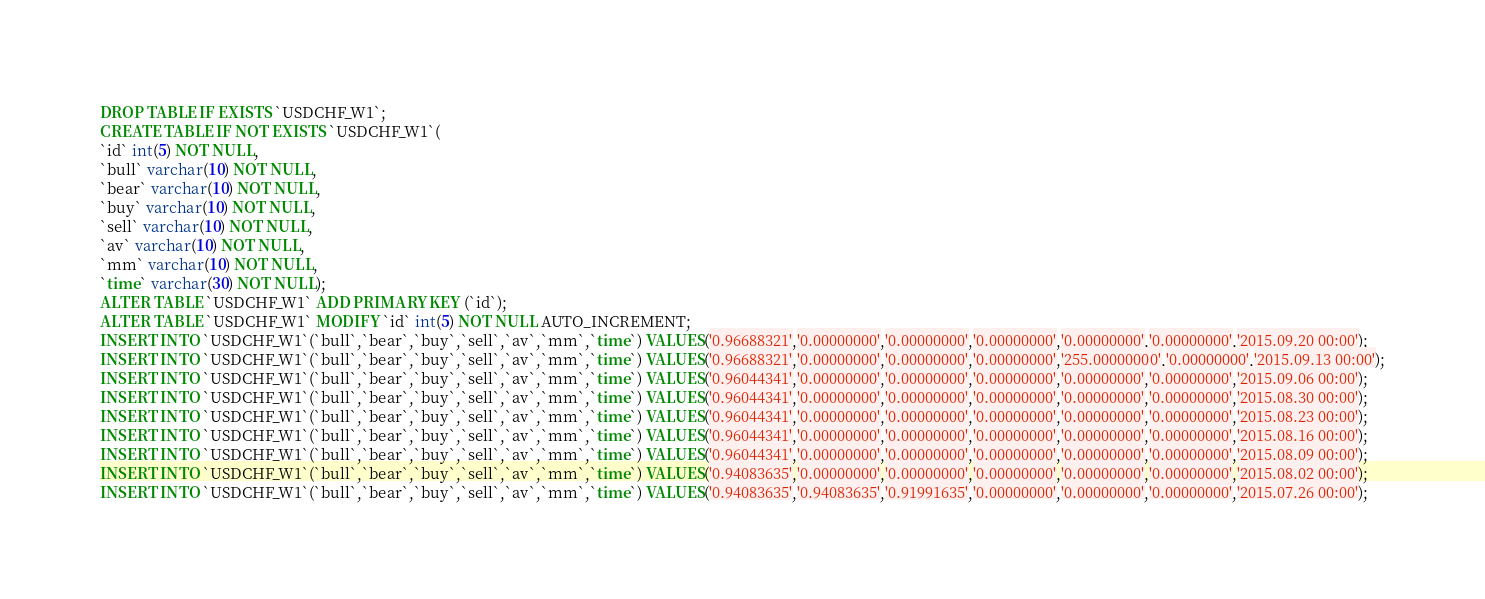<code> <loc_0><loc_0><loc_500><loc_500><_SQL_>DROP TABLE IF EXISTS `USDCHF_W1`;
CREATE TABLE IF NOT EXISTS `USDCHF_W1`(
`id` int(5) NOT NULL,
`bull` varchar(10) NOT NULL,
`bear` varchar(10) NOT NULL,
`buy` varchar(10) NOT NULL,
`sell` varchar(10) NOT NULL,
`av` varchar(10) NOT NULL,
`mm` varchar(10) NOT NULL,
`time` varchar(30) NOT NULL);
ALTER TABLE `USDCHF_W1` ADD PRIMARY KEY (`id`);
ALTER TABLE `USDCHF_W1` MODIFY `id` int(5) NOT NULL AUTO_INCREMENT;
INSERT INTO `USDCHF_W1`(`bull`,`bear`,`buy`,`sell`,`av`,`mm`,`time`) VALUES('0.96688321','0.00000000','0.00000000','0.00000000','0.00000000','0.00000000','2015.09.20 00:00');
INSERT INTO `USDCHF_W1`(`bull`,`bear`,`buy`,`sell`,`av`,`mm`,`time`) VALUES('0.96688321','0.00000000','0.00000000','0.00000000','255.00000000','0.00000000','2015.09.13 00:00');
INSERT INTO `USDCHF_W1`(`bull`,`bear`,`buy`,`sell`,`av`,`mm`,`time`) VALUES('0.96044341','0.00000000','0.00000000','0.00000000','0.00000000','0.00000000','2015.09.06 00:00');
INSERT INTO `USDCHF_W1`(`bull`,`bear`,`buy`,`sell`,`av`,`mm`,`time`) VALUES('0.96044341','0.00000000','0.00000000','0.00000000','0.00000000','0.00000000','2015.08.30 00:00');
INSERT INTO `USDCHF_W1`(`bull`,`bear`,`buy`,`sell`,`av`,`mm`,`time`) VALUES('0.96044341','0.00000000','0.00000000','0.00000000','0.00000000','0.00000000','2015.08.23 00:00');
INSERT INTO `USDCHF_W1`(`bull`,`bear`,`buy`,`sell`,`av`,`mm`,`time`) VALUES('0.96044341','0.00000000','0.00000000','0.00000000','0.00000000','0.00000000','2015.08.16 00:00');
INSERT INTO `USDCHF_W1`(`bull`,`bear`,`buy`,`sell`,`av`,`mm`,`time`) VALUES('0.96044341','0.00000000','0.00000000','0.00000000','0.00000000','0.00000000','2015.08.09 00:00');
INSERT INTO `USDCHF_W1`(`bull`,`bear`,`buy`,`sell`,`av`,`mm`,`time`) VALUES('0.94083635','0.00000000','0.00000000','0.00000000','0.00000000','0.00000000','2015.08.02 00:00');
INSERT INTO `USDCHF_W1`(`bull`,`bear`,`buy`,`sell`,`av`,`mm`,`time`) VALUES('0.94083635','0.94083635','0.91991635','0.00000000','0.00000000','0.00000000','2015.07.26 00:00');</code> 